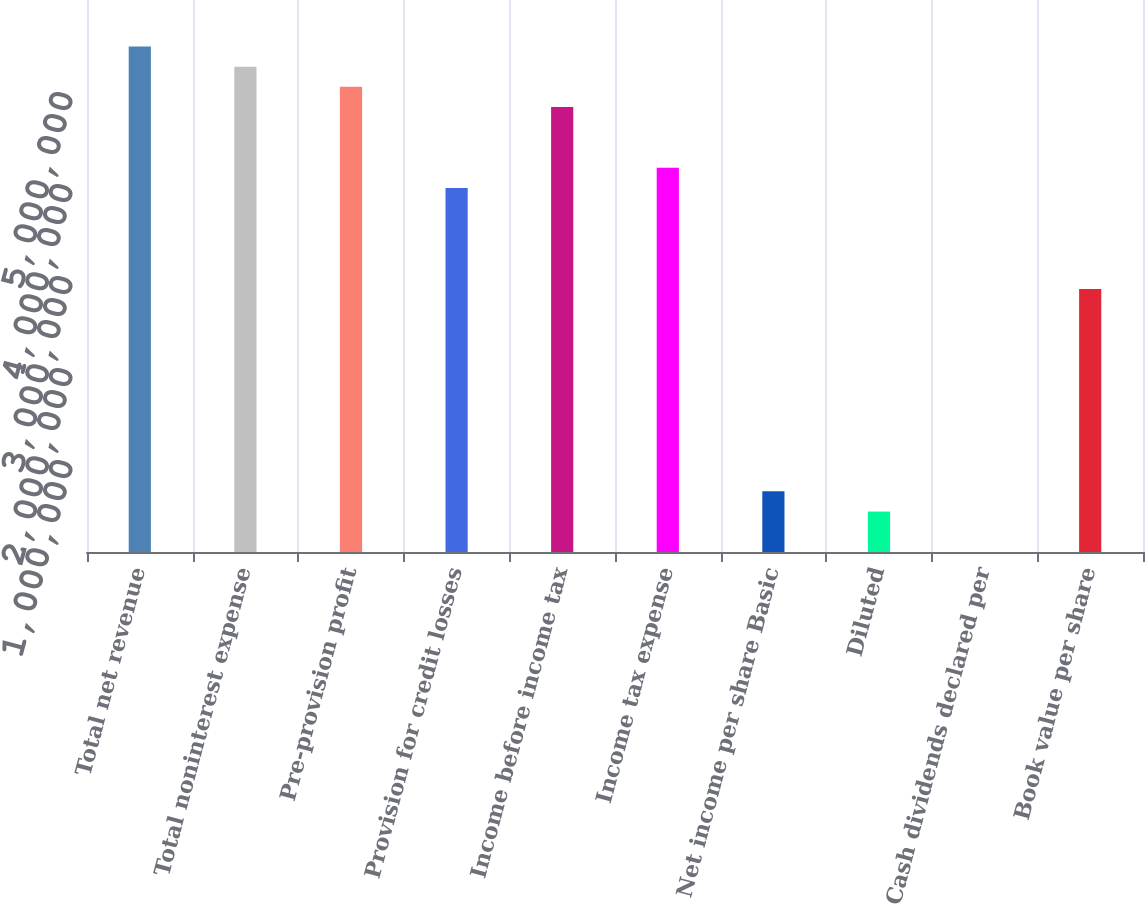Convert chart. <chart><loc_0><loc_0><loc_500><loc_500><bar_chart><fcel>Total net revenue<fcel>Total noninterest expense<fcel>Pre-provision profit<fcel>Provision for credit losses<fcel>Income before income tax<fcel>Income tax expense<fcel>Net income per share Basic<fcel>Diluted<fcel>Cash dividends declared per<fcel>Book value per share<nl><fcel>5.4954e+06<fcel>5.27559e+06<fcel>5.05577e+06<fcel>3.95669e+06<fcel>4.83595e+06<fcel>4.17651e+06<fcel>659448<fcel>439632<fcel>0.25<fcel>2.85761e+06<nl></chart> 